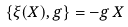<formula> <loc_0><loc_0><loc_500><loc_500>\{ \xi ( X ) , g \} = - g \, X</formula> 